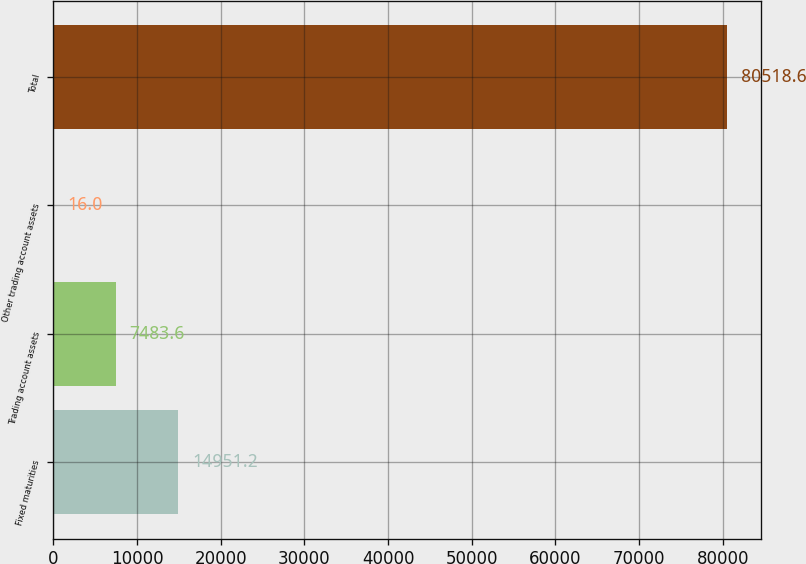Convert chart to OTSL. <chart><loc_0><loc_0><loc_500><loc_500><bar_chart><fcel>Fixed maturities<fcel>Trading account assets<fcel>Other trading account assets<fcel>Total<nl><fcel>14951.2<fcel>7483.6<fcel>16<fcel>80518.6<nl></chart> 